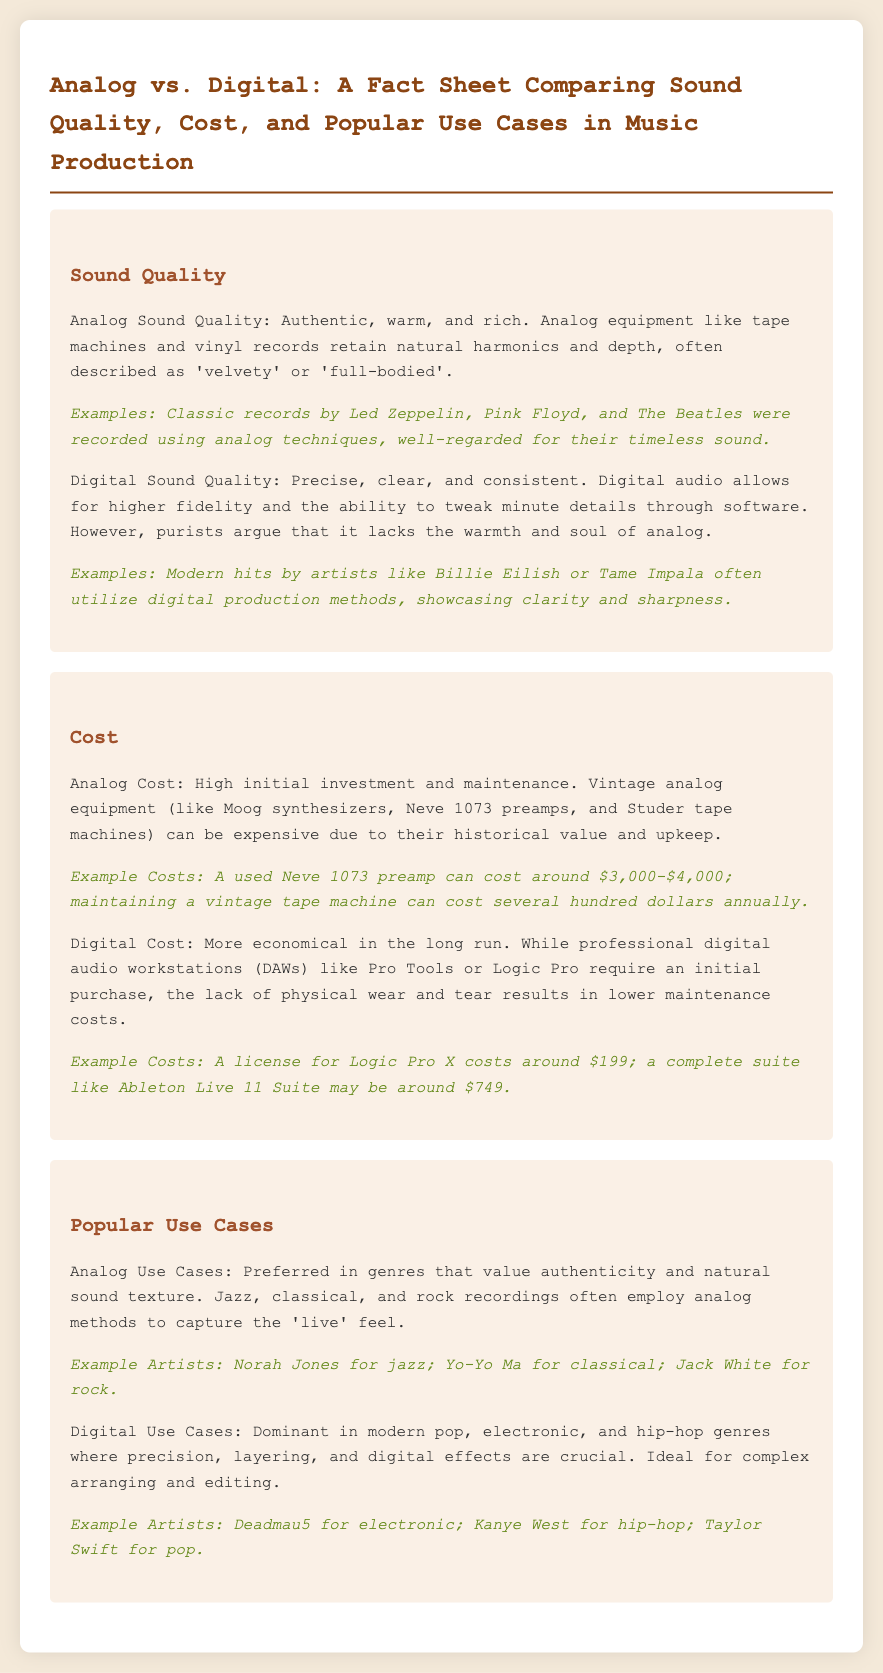What is a notable characteristic of analog sound quality? The document states that analog sound quality is described as 'authentic, warm, and rich'.
Answer: authentic, warm, and rich What is the cost range for a used Neve 1073 preamp? The document provides a cost range of $3,000 to $4,000 for a used Neve 1073 preamp.
Answer: $3,000-$4,000 Which genre prefers analog production methods? The fact sheet indicates that jazz, classical, and rock often employ analog production methods.
Answer: jazz, classical, and rock What is a primary advantage of digital sound quality? It is mentioned that digital sound quality allows for higher fidelity and the ability to tweak minute details.
Answer: higher fidelity Who is an example artist associated with modern pop using digital methods? The document lists Taylor Swift as an example artist for modern pop.
Answer: Taylor Swift What type of music production is often more cost-effective over time? The document states that digital production is more economical in the long run.
Answer: digital production Which vintage equipment is noted for high maintenance costs? The document mentions that maintaining a vintage tape machine can incur several hundred dollars in annual costs.
Answer: vintage tape machine Which artist is cited as an example for electronic music? The document lists Deadmau5 as an example artist for electronic music.
Answer: Deadmau5 